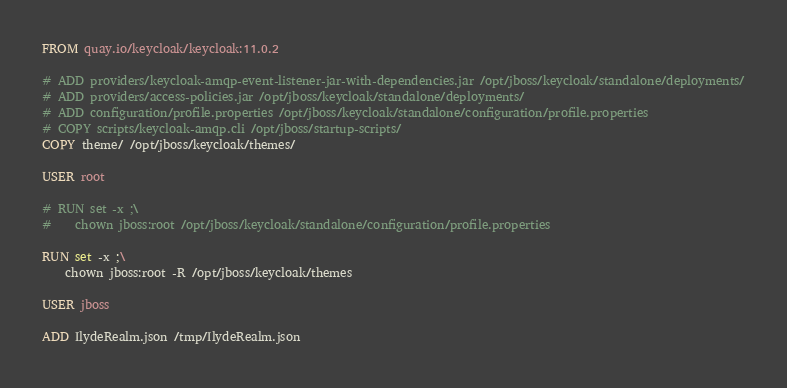Convert code to text. <code><loc_0><loc_0><loc_500><loc_500><_Dockerfile_>FROM quay.io/keycloak/keycloak:11.0.2

# ADD providers/keycloak-amqp-event-listener-jar-with-dependencies.jar /opt/jboss/keycloak/standalone/deployments/
# ADD providers/access-policies.jar /opt/jboss/keycloak/standalone/deployments/
# ADD configuration/profile.properties /opt/jboss/keycloak/standalone/configuration/profile.properties
# COPY scripts/keycloak-amqp.cli /opt/jboss/startup-scripts/
COPY theme/ /opt/jboss/keycloak/themes/

USER root

# RUN set -x ;\
#    chown jboss:root /opt/jboss/keycloak/standalone/configuration/profile.properties

RUN set -x ;\
    chown jboss:root -R /opt/jboss/keycloak/themes

USER jboss

ADD IlydeRealm.json /tmp/IlydeRealm.json

</code> 